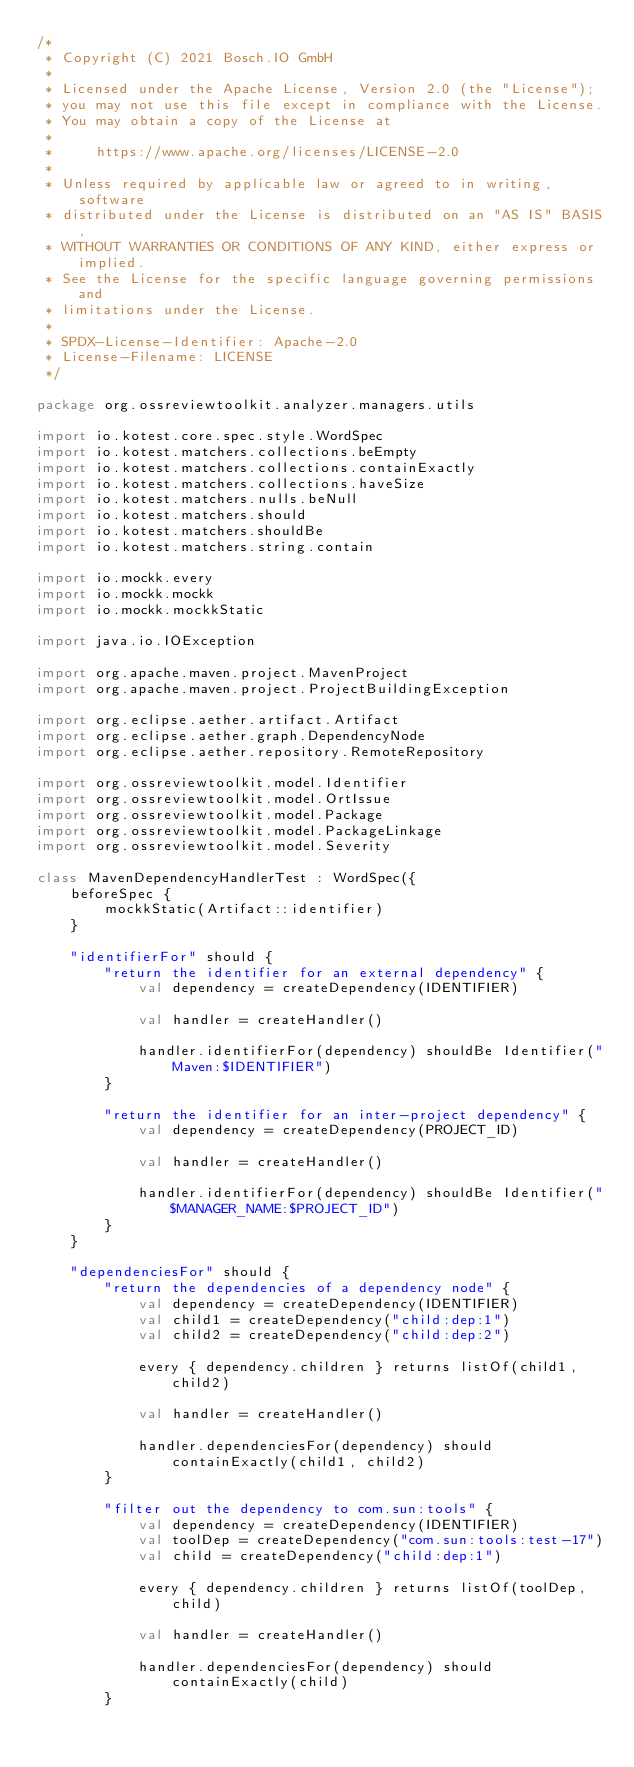Convert code to text. <code><loc_0><loc_0><loc_500><loc_500><_Kotlin_>/*
 * Copyright (C) 2021 Bosch.IO GmbH
 *
 * Licensed under the Apache License, Version 2.0 (the "License");
 * you may not use this file except in compliance with the License.
 * You may obtain a copy of the License at
 *
 *     https://www.apache.org/licenses/LICENSE-2.0
 *
 * Unless required by applicable law or agreed to in writing, software
 * distributed under the License is distributed on an "AS IS" BASIS,
 * WITHOUT WARRANTIES OR CONDITIONS OF ANY KIND, either express or implied.
 * See the License for the specific language governing permissions and
 * limitations under the License.
 *
 * SPDX-License-Identifier: Apache-2.0
 * License-Filename: LICENSE
 */

package org.ossreviewtoolkit.analyzer.managers.utils

import io.kotest.core.spec.style.WordSpec
import io.kotest.matchers.collections.beEmpty
import io.kotest.matchers.collections.containExactly
import io.kotest.matchers.collections.haveSize
import io.kotest.matchers.nulls.beNull
import io.kotest.matchers.should
import io.kotest.matchers.shouldBe
import io.kotest.matchers.string.contain

import io.mockk.every
import io.mockk.mockk
import io.mockk.mockkStatic

import java.io.IOException

import org.apache.maven.project.MavenProject
import org.apache.maven.project.ProjectBuildingException

import org.eclipse.aether.artifact.Artifact
import org.eclipse.aether.graph.DependencyNode
import org.eclipse.aether.repository.RemoteRepository

import org.ossreviewtoolkit.model.Identifier
import org.ossreviewtoolkit.model.OrtIssue
import org.ossreviewtoolkit.model.Package
import org.ossreviewtoolkit.model.PackageLinkage
import org.ossreviewtoolkit.model.Severity

class MavenDependencyHandlerTest : WordSpec({
    beforeSpec {
        mockkStatic(Artifact::identifier)
    }

    "identifierFor" should {
        "return the identifier for an external dependency" {
            val dependency = createDependency(IDENTIFIER)

            val handler = createHandler()

            handler.identifierFor(dependency) shouldBe Identifier("Maven:$IDENTIFIER")
        }

        "return the identifier for an inter-project dependency" {
            val dependency = createDependency(PROJECT_ID)

            val handler = createHandler()

            handler.identifierFor(dependency) shouldBe Identifier("$MANAGER_NAME:$PROJECT_ID")
        }
    }

    "dependenciesFor" should {
        "return the dependencies of a dependency node" {
            val dependency = createDependency(IDENTIFIER)
            val child1 = createDependency("child:dep:1")
            val child2 = createDependency("child:dep:2")

            every { dependency.children } returns listOf(child1, child2)

            val handler = createHandler()

            handler.dependenciesFor(dependency) should containExactly(child1, child2)
        }

        "filter out the dependency to com.sun:tools" {
            val dependency = createDependency(IDENTIFIER)
            val toolDep = createDependency("com.sun:tools:test-17")
            val child = createDependency("child:dep:1")

            every { dependency.children } returns listOf(toolDep, child)

            val handler = createHandler()

            handler.dependenciesFor(dependency) should containExactly(child)
        }
</code> 